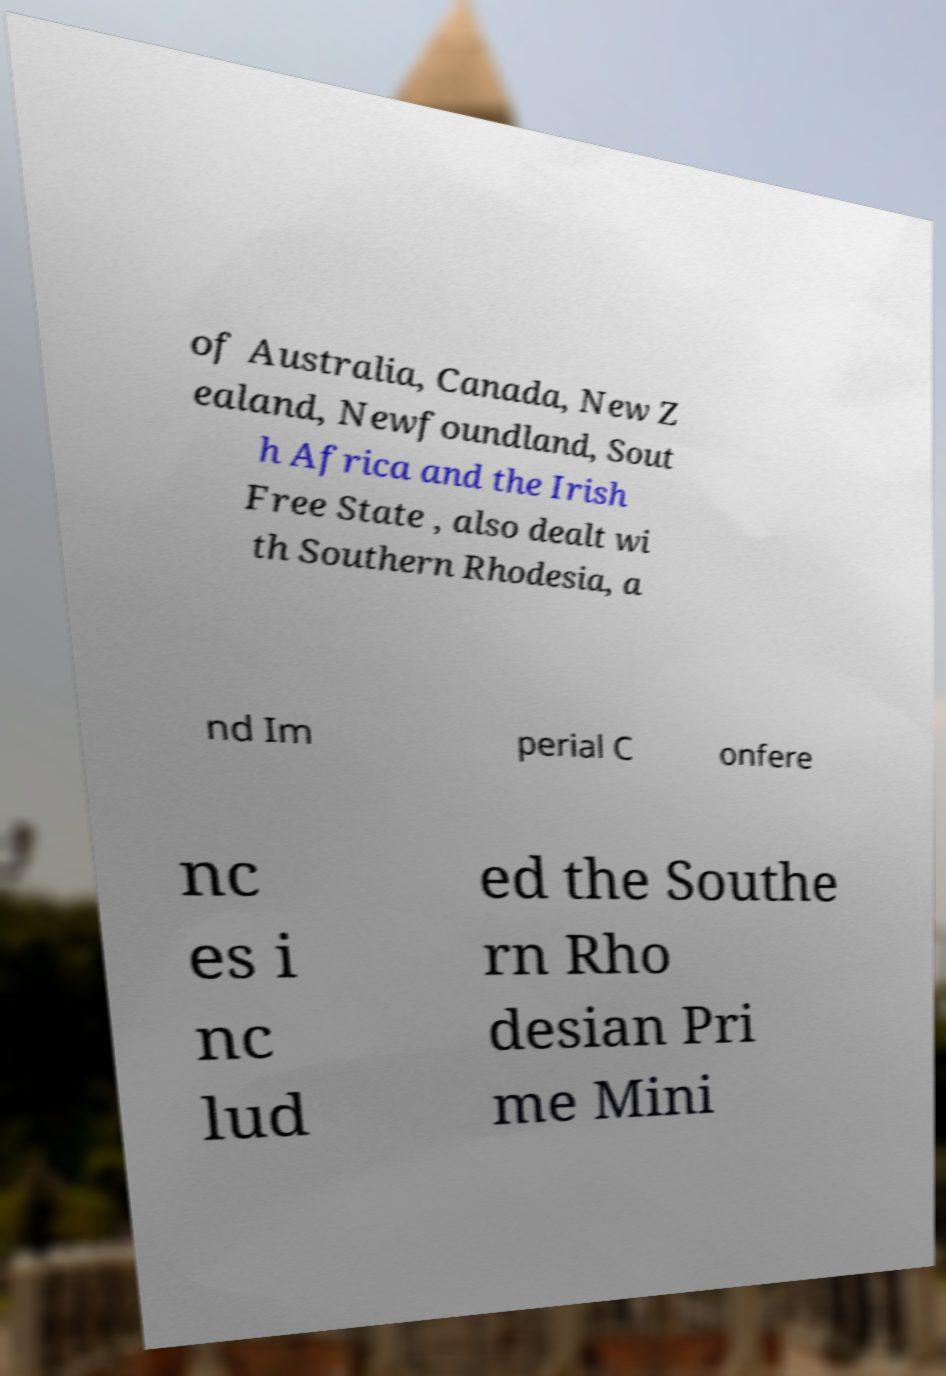Can you read and provide the text displayed in the image?This photo seems to have some interesting text. Can you extract and type it out for me? of Australia, Canada, New Z ealand, Newfoundland, Sout h Africa and the Irish Free State , also dealt wi th Southern Rhodesia, a nd Im perial C onfere nc es i nc lud ed the Southe rn Rho desian Pri me Mini 